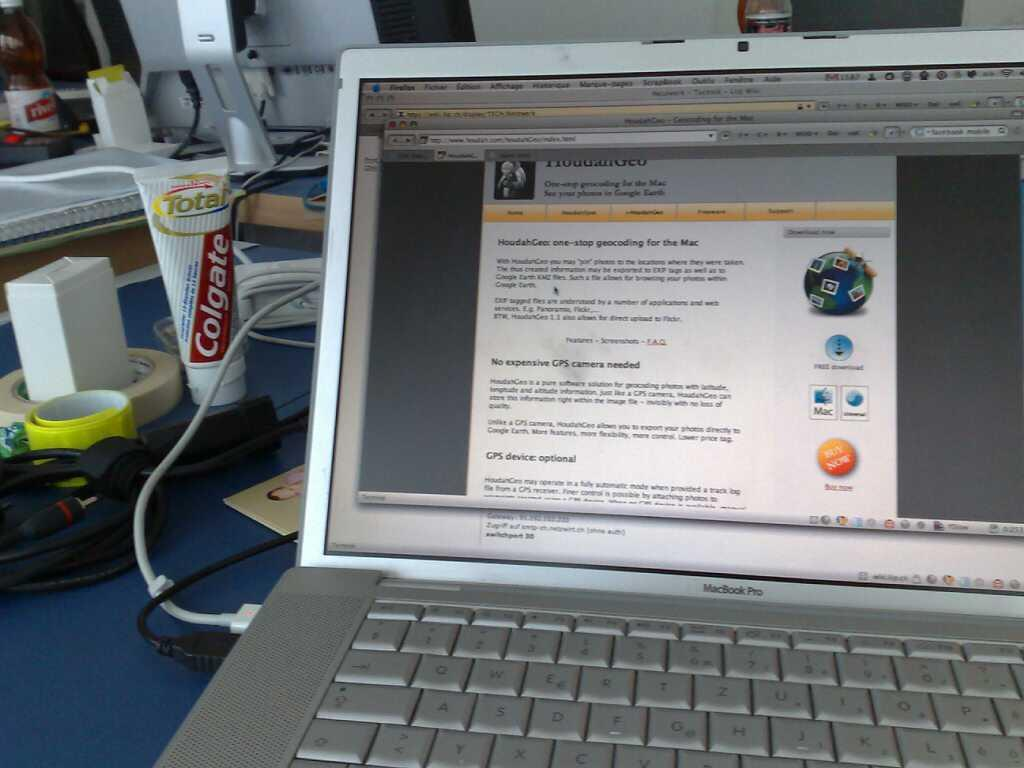<image>
Render a clear and concise summary of the photo. macbook pro laptop that has a page on geocoding for the mac pulled up and a tube of colgate toothpaste in the background 